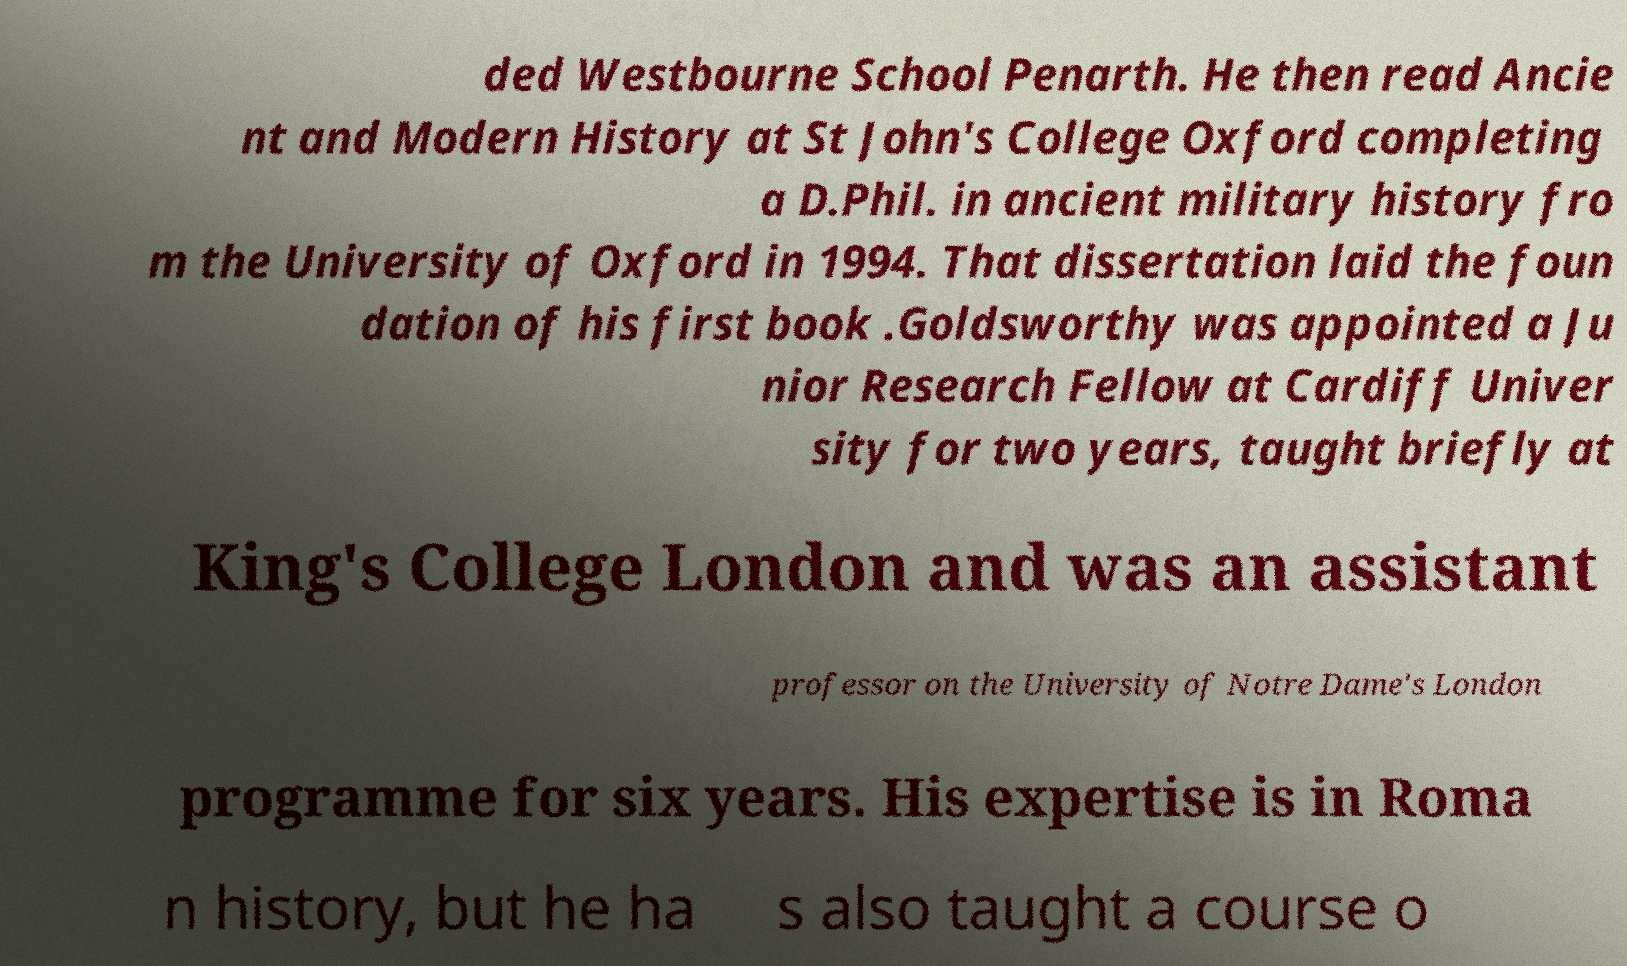For documentation purposes, I need the text within this image transcribed. Could you provide that? ded Westbourne School Penarth. He then read Ancie nt and Modern History at St John's College Oxford completing a D.Phil. in ancient military history fro m the University of Oxford in 1994. That dissertation laid the foun dation of his first book .Goldsworthy was appointed a Ju nior Research Fellow at Cardiff Univer sity for two years, taught briefly at King's College London and was an assistant professor on the University of Notre Dame's London programme for six years. His expertise is in Roma n history, but he ha s also taught a course o 